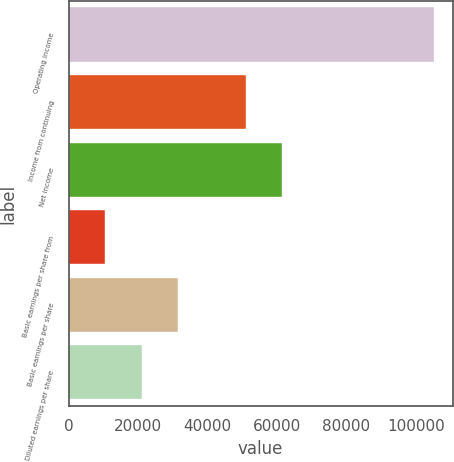Convert chart to OTSL. <chart><loc_0><loc_0><loc_500><loc_500><bar_chart><fcel>Operating income<fcel>Income from continuing<fcel>Net income<fcel>Basic earnings per share from<fcel>Basic earnings per share<fcel>Diluted earnings per share<nl><fcel>105298<fcel>50914<fcel>61443.8<fcel>10530.2<fcel>31589.7<fcel>21060<nl></chart> 